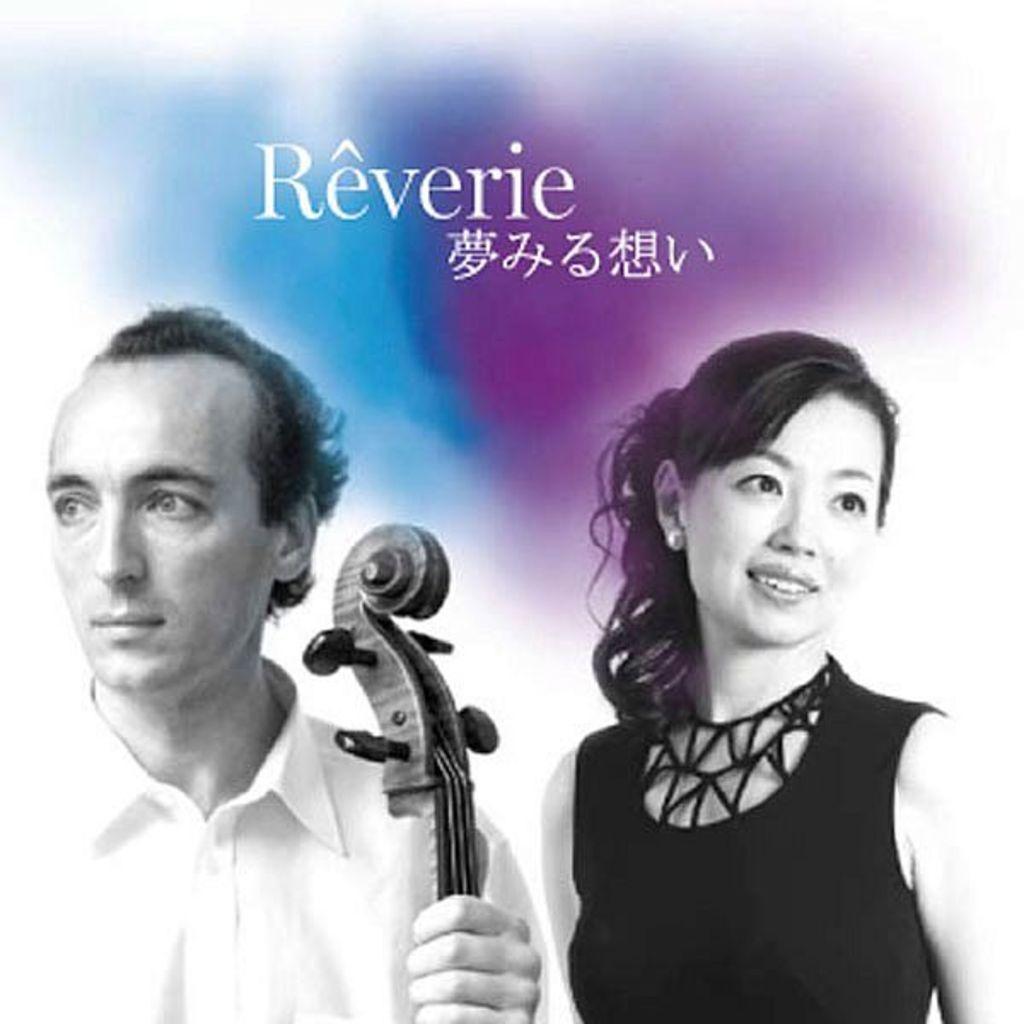Please provide a concise description of this image. This is an image in the left side a man is there, he wore a white color shirt. In the right side a beautiful girl is there, she wore a black color dress. 